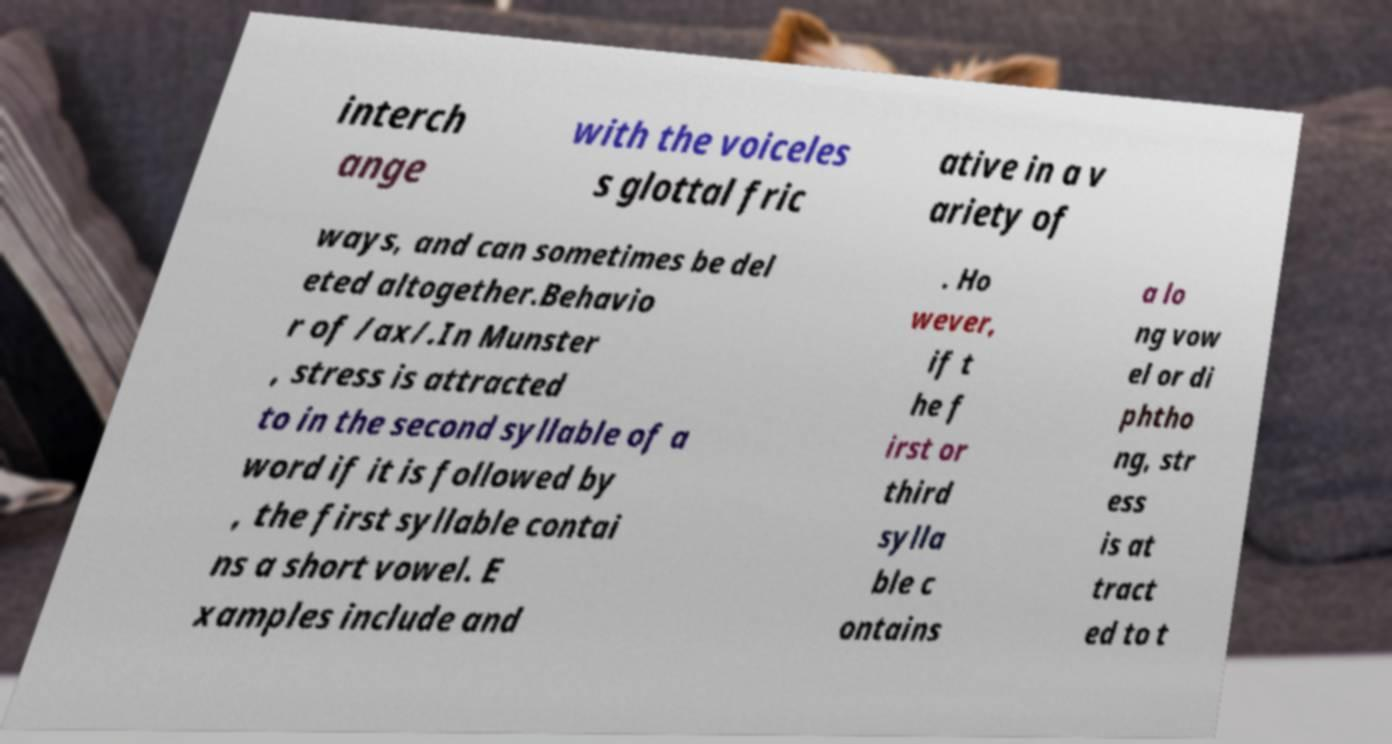What messages or text are displayed in this image? I need them in a readable, typed format. interch ange with the voiceles s glottal fric ative in a v ariety of ways, and can sometimes be del eted altogether.Behavio r of /ax/.In Munster , stress is attracted to in the second syllable of a word if it is followed by , the first syllable contai ns a short vowel. E xamples include and . Ho wever, if t he f irst or third sylla ble c ontains a lo ng vow el or di phtho ng, str ess is at tract ed to t 